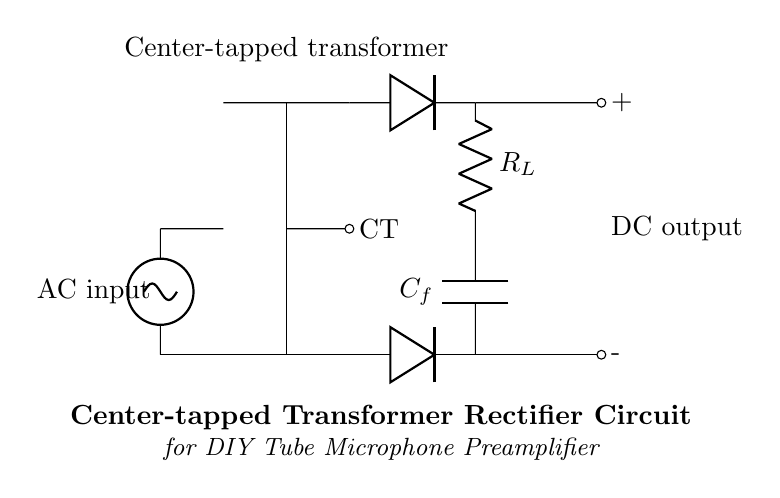What type of transformer is used in this circuit? The circuit uses a center-tapped transformer, indicated by the labeling "CT" and the configuration of the transformer core.
Answer: Center-tapped How many diodes are present in the circuit? The circuit has two diodes, both illustrated parallel to the output and connected to the transformer leads.
Answer: Two What does the capacitor in this circuit do? The capacitor acts as a filter capacitor, smoothing out the rectified output by reducing the ripple voltage to provide a more stable DC output.
Answer: Smoothes output What is the output voltage type of the circuit? The output voltage type is DC, as indicated by the labelled output terminals (+ for positive, - for negative).
Answer: DC Which component limits the current to the load in this circuit? The resistor labeled R_L limits the current to the load connected in the output circuit, providing a resistive path for the flow of current from the capacitor.
Answer: Resistor What is the function of the transformer in this rectifier circuit? The transformer steps down or steps up the AC voltage level from the source to an appropriate level for rectification, crucial for converting AC to DC.
Answer: Voltage conversion What might happen if a non-center-tapped transformer were used instead? If a non-center-tapped transformer were used, the rectification would likely be less effective, leading to higher ripple voltage and unstable DC output due to the lack of a reference point.
Answer: Ineffective rectification 